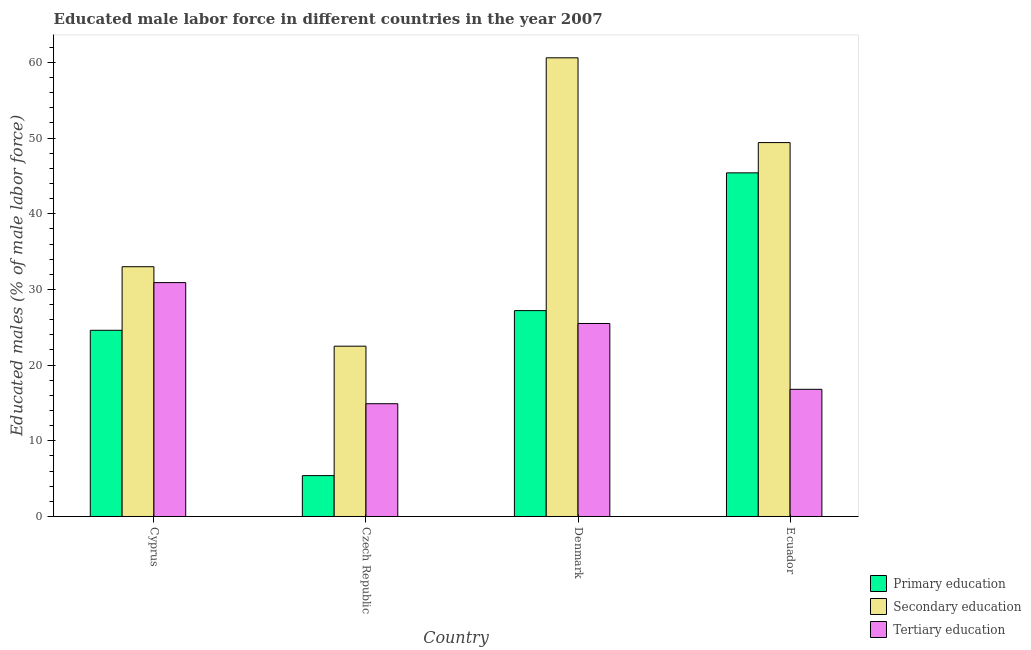How many different coloured bars are there?
Your response must be concise. 3. What is the label of the 4th group of bars from the left?
Offer a very short reply. Ecuador. What is the percentage of male labor force who received secondary education in Ecuador?
Offer a very short reply. 49.4. Across all countries, what is the maximum percentage of male labor force who received secondary education?
Your answer should be compact. 60.6. Across all countries, what is the minimum percentage of male labor force who received primary education?
Provide a short and direct response. 5.4. In which country was the percentage of male labor force who received tertiary education maximum?
Provide a succinct answer. Cyprus. In which country was the percentage of male labor force who received primary education minimum?
Offer a very short reply. Czech Republic. What is the total percentage of male labor force who received secondary education in the graph?
Offer a very short reply. 165.5. What is the difference between the percentage of male labor force who received tertiary education in Denmark and that in Ecuador?
Provide a succinct answer. 8.7. What is the difference between the percentage of male labor force who received primary education in Denmark and the percentage of male labor force who received tertiary education in Ecuador?
Your answer should be compact. 10.4. What is the average percentage of male labor force who received secondary education per country?
Your answer should be compact. 41.38. What is the difference between the percentage of male labor force who received tertiary education and percentage of male labor force who received primary education in Denmark?
Your response must be concise. -1.7. In how many countries, is the percentage of male labor force who received primary education greater than 2 %?
Offer a terse response. 4. What is the ratio of the percentage of male labor force who received tertiary education in Cyprus to that in Denmark?
Ensure brevity in your answer.  1.21. Is the difference between the percentage of male labor force who received secondary education in Cyprus and Denmark greater than the difference between the percentage of male labor force who received tertiary education in Cyprus and Denmark?
Offer a very short reply. No. What is the difference between the highest and the second highest percentage of male labor force who received primary education?
Your response must be concise. 18.2. What is the difference between the highest and the lowest percentage of male labor force who received secondary education?
Your response must be concise. 38.1. Is the sum of the percentage of male labor force who received primary education in Cyprus and Denmark greater than the maximum percentage of male labor force who received secondary education across all countries?
Ensure brevity in your answer.  No. What does the 2nd bar from the right in Ecuador represents?
Keep it short and to the point. Secondary education. Are all the bars in the graph horizontal?
Provide a succinct answer. No. What is the difference between two consecutive major ticks on the Y-axis?
Your answer should be very brief. 10. What is the title of the graph?
Provide a succinct answer. Educated male labor force in different countries in the year 2007. What is the label or title of the X-axis?
Provide a succinct answer. Country. What is the label or title of the Y-axis?
Offer a terse response. Educated males (% of male labor force). What is the Educated males (% of male labor force) in Primary education in Cyprus?
Offer a very short reply. 24.6. What is the Educated males (% of male labor force) in Secondary education in Cyprus?
Provide a short and direct response. 33. What is the Educated males (% of male labor force) in Tertiary education in Cyprus?
Give a very brief answer. 30.9. What is the Educated males (% of male labor force) of Primary education in Czech Republic?
Your answer should be very brief. 5.4. What is the Educated males (% of male labor force) in Secondary education in Czech Republic?
Offer a terse response. 22.5. What is the Educated males (% of male labor force) in Tertiary education in Czech Republic?
Provide a short and direct response. 14.9. What is the Educated males (% of male labor force) of Primary education in Denmark?
Offer a terse response. 27.2. What is the Educated males (% of male labor force) in Secondary education in Denmark?
Give a very brief answer. 60.6. What is the Educated males (% of male labor force) in Primary education in Ecuador?
Provide a succinct answer. 45.4. What is the Educated males (% of male labor force) of Secondary education in Ecuador?
Keep it short and to the point. 49.4. What is the Educated males (% of male labor force) in Tertiary education in Ecuador?
Give a very brief answer. 16.8. Across all countries, what is the maximum Educated males (% of male labor force) of Primary education?
Your answer should be very brief. 45.4. Across all countries, what is the maximum Educated males (% of male labor force) in Secondary education?
Ensure brevity in your answer.  60.6. Across all countries, what is the maximum Educated males (% of male labor force) in Tertiary education?
Keep it short and to the point. 30.9. Across all countries, what is the minimum Educated males (% of male labor force) in Primary education?
Give a very brief answer. 5.4. Across all countries, what is the minimum Educated males (% of male labor force) of Secondary education?
Give a very brief answer. 22.5. Across all countries, what is the minimum Educated males (% of male labor force) of Tertiary education?
Your answer should be very brief. 14.9. What is the total Educated males (% of male labor force) of Primary education in the graph?
Offer a very short reply. 102.6. What is the total Educated males (% of male labor force) in Secondary education in the graph?
Ensure brevity in your answer.  165.5. What is the total Educated males (% of male labor force) of Tertiary education in the graph?
Your answer should be very brief. 88.1. What is the difference between the Educated males (% of male labor force) of Tertiary education in Cyprus and that in Czech Republic?
Provide a succinct answer. 16. What is the difference between the Educated males (% of male labor force) in Secondary education in Cyprus and that in Denmark?
Make the answer very short. -27.6. What is the difference between the Educated males (% of male labor force) of Primary education in Cyprus and that in Ecuador?
Offer a terse response. -20.8. What is the difference between the Educated males (% of male labor force) in Secondary education in Cyprus and that in Ecuador?
Your response must be concise. -16.4. What is the difference between the Educated males (% of male labor force) in Primary education in Czech Republic and that in Denmark?
Provide a succinct answer. -21.8. What is the difference between the Educated males (% of male labor force) in Secondary education in Czech Republic and that in Denmark?
Provide a short and direct response. -38.1. What is the difference between the Educated males (% of male labor force) in Tertiary education in Czech Republic and that in Denmark?
Offer a terse response. -10.6. What is the difference between the Educated males (% of male labor force) in Primary education in Czech Republic and that in Ecuador?
Make the answer very short. -40. What is the difference between the Educated males (% of male labor force) of Secondary education in Czech Republic and that in Ecuador?
Ensure brevity in your answer.  -26.9. What is the difference between the Educated males (% of male labor force) in Primary education in Denmark and that in Ecuador?
Your response must be concise. -18.2. What is the difference between the Educated males (% of male labor force) of Secondary education in Cyprus and the Educated males (% of male labor force) of Tertiary education in Czech Republic?
Provide a short and direct response. 18.1. What is the difference between the Educated males (% of male labor force) of Primary education in Cyprus and the Educated males (% of male labor force) of Secondary education in Denmark?
Offer a terse response. -36. What is the difference between the Educated males (% of male labor force) of Primary education in Cyprus and the Educated males (% of male labor force) of Tertiary education in Denmark?
Your response must be concise. -0.9. What is the difference between the Educated males (% of male labor force) in Secondary education in Cyprus and the Educated males (% of male labor force) in Tertiary education in Denmark?
Keep it short and to the point. 7.5. What is the difference between the Educated males (% of male labor force) in Primary education in Cyprus and the Educated males (% of male labor force) in Secondary education in Ecuador?
Provide a succinct answer. -24.8. What is the difference between the Educated males (% of male labor force) in Secondary education in Cyprus and the Educated males (% of male labor force) in Tertiary education in Ecuador?
Your answer should be very brief. 16.2. What is the difference between the Educated males (% of male labor force) in Primary education in Czech Republic and the Educated males (% of male labor force) in Secondary education in Denmark?
Provide a short and direct response. -55.2. What is the difference between the Educated males (% of male labor force) in Primary education in Czech Republic and the Educated males (% of male labor force) in Tertiary education in Denmark?
Ensure brevity in your answer.  -20.1. What is the difference between the Educated males (% of male labor force) in Secondary education in Czech Republic and the Educated males (% of male labor force) in Tertiary education in Denmark?
Your response must be concise. -3. What is the difference between the Educated males (% of male labor force) in Primary education in Czech Republic and the Educated males (% of male labor force) in Secondary education in Ecuador?
Provide a short and direct response. -44. What is the difference between the Educated males (% of male labor force) in Primary education in Czech Republic and the Educated males (% of male labor force) in Tertiary education in Ecuador?
Provide a succinct answer. -11.4. What is the difference between the Educated males (% of male labor force) in Primary education in Denmark and the Educated males (% of male labor force) in Secondary education in Ecuador?
Offer a terse response. -22.2. What is the difference between the Educated males (% of male labor force) in Secondary education in Denmark and the Educated males (% of male labor force) in Tertiary education in Ecuador?
Keep it short and to the point. 43.8. What is the average Educated males (% of male labor force) in Primary education per country?
Offer a terse response. 25.65. What is the average Educated males (% of male labor force) in Secondary education per country?
Offer a very short reply. 41.38. What is the average Educated males (% of male labor force) of Tertiary education per country?
Provide a succinct answer. 22.02. What is the difference between the Educated males (% of male labor force) in Primary education and Educated males (% of male labor force) in Secondary education in Cyprus?
Ensure brevity in your answer.  -8.4. What is the difference between the Educated males (% of male labor force) of Primary education and Educated males (% of male labor force) of Tertiary education in Cyprus?
Offer a very short reply. -6.3. What is the difference between the Educated males (% of male labor force) of Primary education and Educated males (% of male labor force) of Secondary education in Czech Republic?
Give a very brief answer. -17.1. What is the difference between the Educated males (% of male labor force) of Secondary education and Educated males (% of male labor force) of Tertiary education in Czech Republic?
Keep it short and to the point. 7.6. What is the difference between the Educated males (% of male labor force) of Primary education and Educated males (% of male labor force) of Secondary education in Denmark?
Offer a terse response. -33.4. What is the difference between the Educated males (% of male labor force) in Primary education and Educated males (% of male labor force) in Tertiary education in Denmark?
Give a very brief answer. 1.7. What is the difference between the Educated males (% of male labor force) in Secondary education and Educated males (% of male labor force) in Tertiary education in Denmark?
Your answer should be very brief. 35.1. What is the difference between the Educated males (% of male labor force) of Primary education and Educated males (% of male labor force) of Tertiary education in Ecuador?
Give a very brief answer. 28.6. What is the difference between the Educated males (% of male labor force) in Secondary education and Educated males (% of male labor force) in Tertiary education in Ecuador?
Keep it short and to the point. 32.6. What is the ratio of the Educated males (% of male labor force) of Primary education in Cyprus to that in Czech Republic?
Your response must be concise. 4.56. What is the ratio of the Educated males (% of male labor force) of Secondary education in Cyprus to that in Czech Republic?
Offer a very short reply. 1.47. What is the ratio of the Educated males (% of male labor force) in Tertiary education in Cyprus to that in Czech Republic?
Make the answer very short. 2.07. What is the ratio of the Educated males (% of male labor force) in Primary education in Cyprus to that in Denmark?
Make the answer very short. 0.9. What is the ratio of the Educated males (% of male labor force) of Secondary education in Cyprus to that in Denmark?
Ensure brevity in your answer.  0.54. What is the ratio of the Educated males (% of male labor force) of Tertiary education in Cyprus to that in Denmark?
Your answer should be compact. 1.21. What is the ratio of the Educated males (% of male labor force) of Primary education in Cyprus to that in Ecuador?
Provide a succinct answer. 0.54. What is the ratio of the Educated males (% of male labor force) in Secondary education in Cyprus to that in Ecuador?
Your answer should be compact. 0.67. What is the ratio of the Educated males (% of male labor force) of Tertiary education in Cyprus to that in Ecuador?
Give a very brief answer. 1.84. What is the ratio of the Educated males (% of male labor force) in Primary education in Czech Republic to that in Denmark?
Provide a succinct answer. 0.2. What is the ratio of the Educated males (% of male labor force) in Secondary education in Czech Republic to that in Denmark?
Make the answer very short. 0.37. What is the ratio of the Educated males (% of male labor force) in Tertiary education in Czech Republic to that in Denmark?
Make the answer very short. 0.58. What is the ratio of the Educated males (% of male labor force) of Primary education in Czech Republic to that in Ecuador?
Ensure brevity in your answer.  0.12. What is the ratio of the Educated males (% of male labor force) of Secondary education in Czech Republic to that in Ecuador?
Your answer should be very brief. 0.46. What is the ratio of the Educated males (% of male labor force) in Tertiary education in Czech Republic to that in Ecuador?
Keep it short and to the point. 0.89. What is the ratio of the Educated males (% of male labor force) in Primary education in Denmark to that in Ecuador?
Provide a succinct answer. 0.6. What is the ratio of the Educated males (% of male labor force) in Secondary education in Denmark to that in Ecuador?
Provide a succinct answer. 1.23. What is the ratio of the Educated males (% of male labor force) of Tertiary education in Denmark to that in Ecuador?
Make the answer very short. 1.52. What is the difference between the highest and the second highest Educated males (% of male labor force) in Secondary education?
Keep it short and to the point. 11.2. What is the difference between the highest and the lowest Educated males (% of male labor force) of Primary education?
Your answer should be very brief. 40. What is the difference between the highest and the lowest Educated males (% of male labor force) of Secondary education?
Ensure brevity in your answer.  38.1. What is the difference between the highest and the lowest Educated males (% of male labor force) in Tertiary education?
Give a very brief answer. 16. 